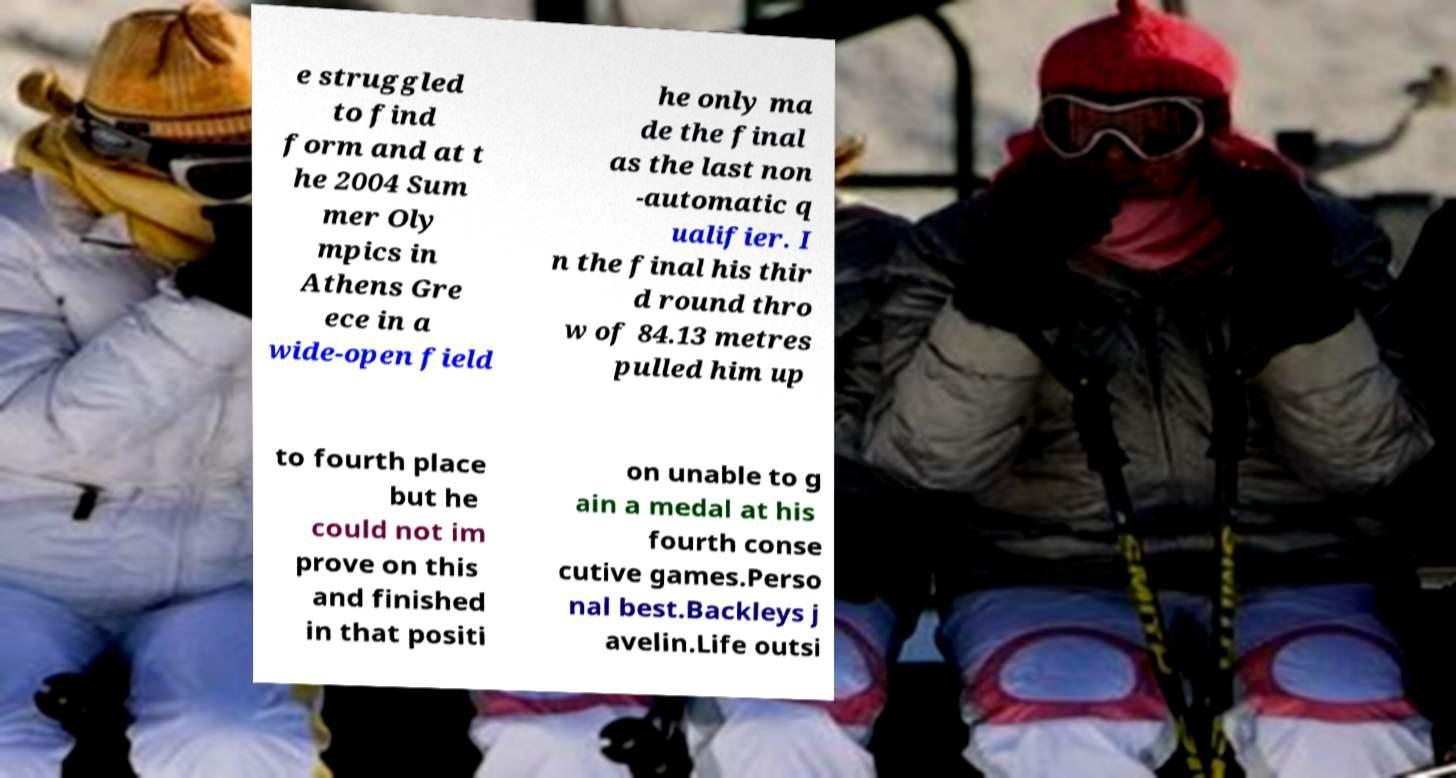Could you assist in decoding the text presented in this image and type it out clearly? e struggled to find form and at t he 2004 Sum mer Oly mpics in Athens Gre ece in a wide-open field he only ma de the final as the last non -automatic q ualifier. I n the final his thir d round thro w of 84.13 metres pulled him up to fourth place but he could not im prove on this and finished in that positi on unable to g ain a medal at his fourth conse cutive games.Perso nal best.Backleys j avelin.Life outsi 